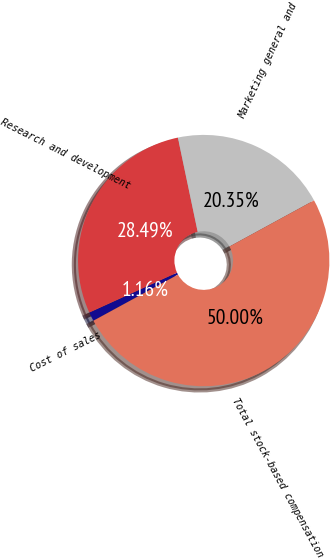Convert chart to OTSL. <chart><loc_0><loc_0><loc_500><loc_500><pie_chart><fcel>Cost of sales<fcel>Research and development<fcel>Marketing general and<fcel>Total stock-based compensation<nl><fcel>1.16%<fcel>28.49%<fcel>20.35%<fcel>50.0%<nl></chart> 